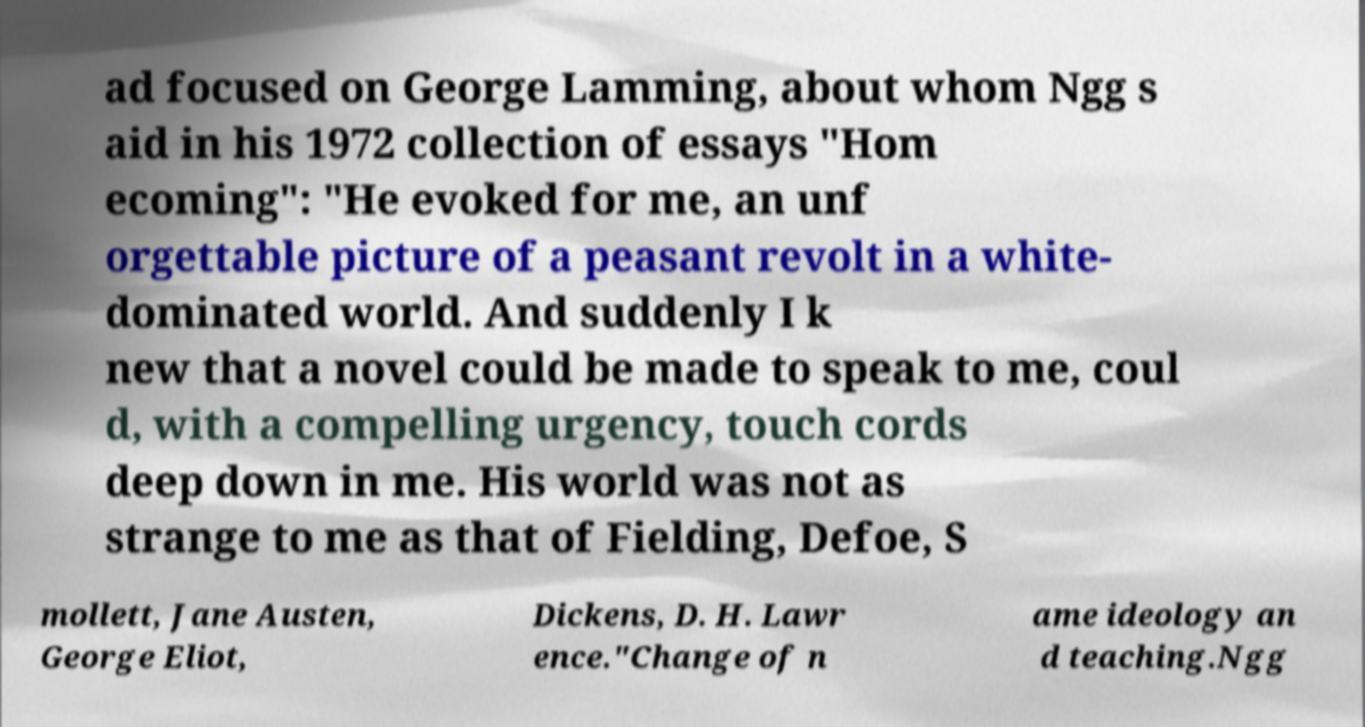For documentation purposes, I need the text within this image transcribed. Could you provide that? ad focused on George Lamming, about whom Ngg s aid in his 1972 collection of essays "Hom ecoming": "He evoked for me, an unf orgettable picture of a peasant revolt in a white- dominated world. And suddenly I k new that a novel could be made to speak to me, coul d, with a compelling urgency, touch cords deep down in me. His world was not as strange to me as that of Fielding, Defoe, S mollett, Jane Austen, George Eliot, Dickens, D. H. Lawr ence."Change of n ame ideology an d teaching.Ngg 